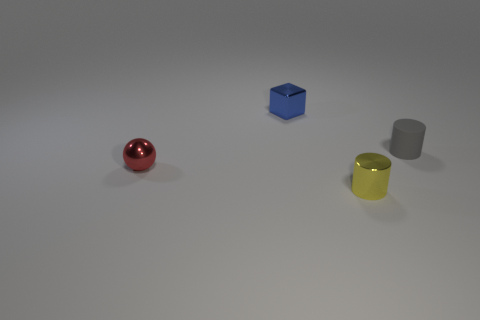Subtract all yellow cylinders. How many cylinders are left? 1 Add 1 tiny red balls. How many objects exist? 5 Subtract all balls. How many objects are left? 3 Subtract 0 brown spheres. How many objects are left? 4 Subtract all big metallic cylinders. Subtract all tiny matte cylinders. How many objects are left? 3 Add 4 small metallic cylinders. How many small metallic cylinders are left? 5 Add 2 cyan shiny things. How many cyan shiny things exist? 2 